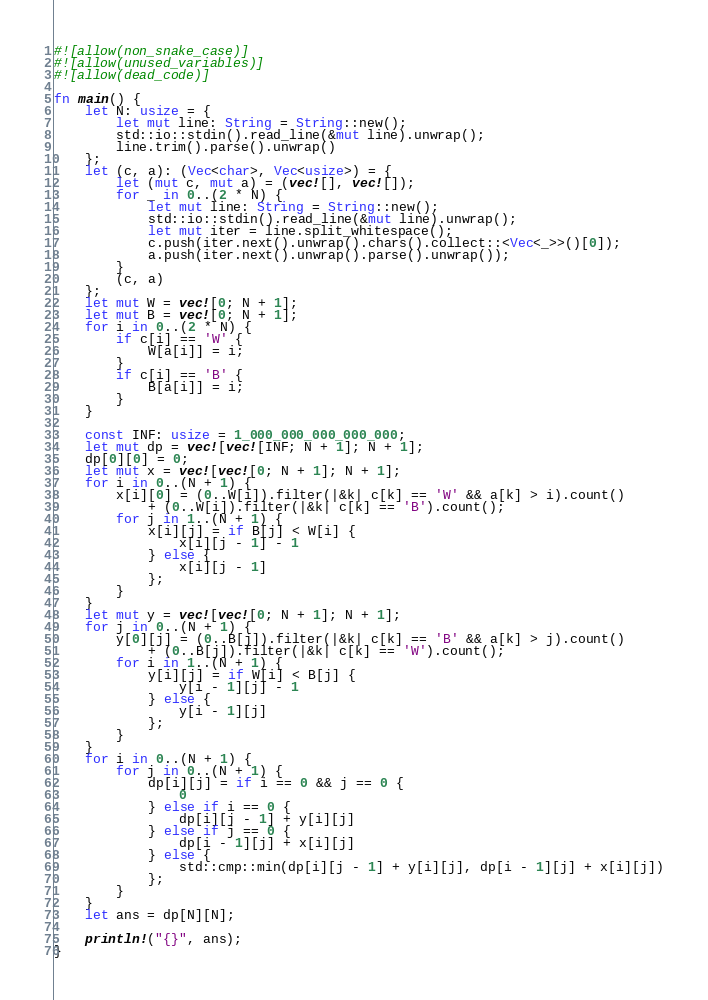Convert code to text. <code><loc_0><loc_0><loc_500><loc_500><_Rust_>#![allow(non_snake_case)]
#![allow(unused_variables)]
#![allow(dead_code)]

fn main() {
    let N: usize = {
        let mut line: String = String::new();
        std::io::stdin().read_line(&mut line).unwrap();
        line.trim().parse().unwrap()
    };
    let (c, a): (Vec<char>, Vec<usize>) = {
        let (mut c, mut a) = (vec![], vec![]);
        for _ in 0..(2 * N) {
            let mut line: String = String::new();
            std::io::stdin().read_line(&mut line).unwrap();
            let mut iter = line.split_whitespace();
            c.push(iter.next().unwrap().chars().collect::<Vec<_>>()[0]);
            a.push(iter.next().unwrap().parse().unwrap());
        }
        (c, a)
    };
    let mut W = vec![0; N + 1];
    let mut B = vec![0; N + 1];
    for i in 0..(2 * N) {
        if c[i] == 'W' {
            W[a[i]] = i;
        }
        if c[i] == 'B' {
            B[a[i]] = i;
        }
    }

    const INF: usize = 1_000_000_000_000_000;
    let mut dp = vec![vec![INF; N + 1]; N + 1];
    dp[0][0] = 0;
    let mut x = vec![vec![0; N + 1]; N + 1];
    for i in 0..(N + 1) {
        x[i][0] = (0..W[i]).filter(|&k| c[k] == 'W' && a[k] > i).count()
            + (0..W[i]).filter(|&k| c[k] == 'B').count();
        for j in 1..(N + 1) {
            x[i][j] = if B[j] < W[i] {
                x[i][j - 1] - 1
            } else {
                x[i][j - 1]
            };
        }
    }
    let mut y = vec![vec![0; N + 1]; N + 1];
    for j in 0..(N + 1) {
        y[0][j] = (0..B[j]).filter(|&k| c[k] == 'B' && a[k] > j).count()
            + (0..B[j]).filter(|&k| c[k] == 'W').count();
        for i in 1..(N + 1) {
            y[i][j] = if W[i] < B[j] {
                y[i - 1][j] - 1
            } else {
                y[i - 1][j]
            };
        }
    }
    for i in 0..(N + 1) {
        for j in 0..(N + 1) {
            dp[i][j] = if i == 0 && j == 0 {
                0
            } else if i == 0 {
                dp[i][j - 1] + y[i][j]
            } else if j == 0 {
                dp[i - 1][j] + x[i][j]
            } else {
                std::cmp::min(dp[i][j - 1] + y[i][j], dp[i - 1][j] + x[i][j])
            };
        }
    }
    let ans = dp[N][N];

    println!("{}", ans);
}
</code> 